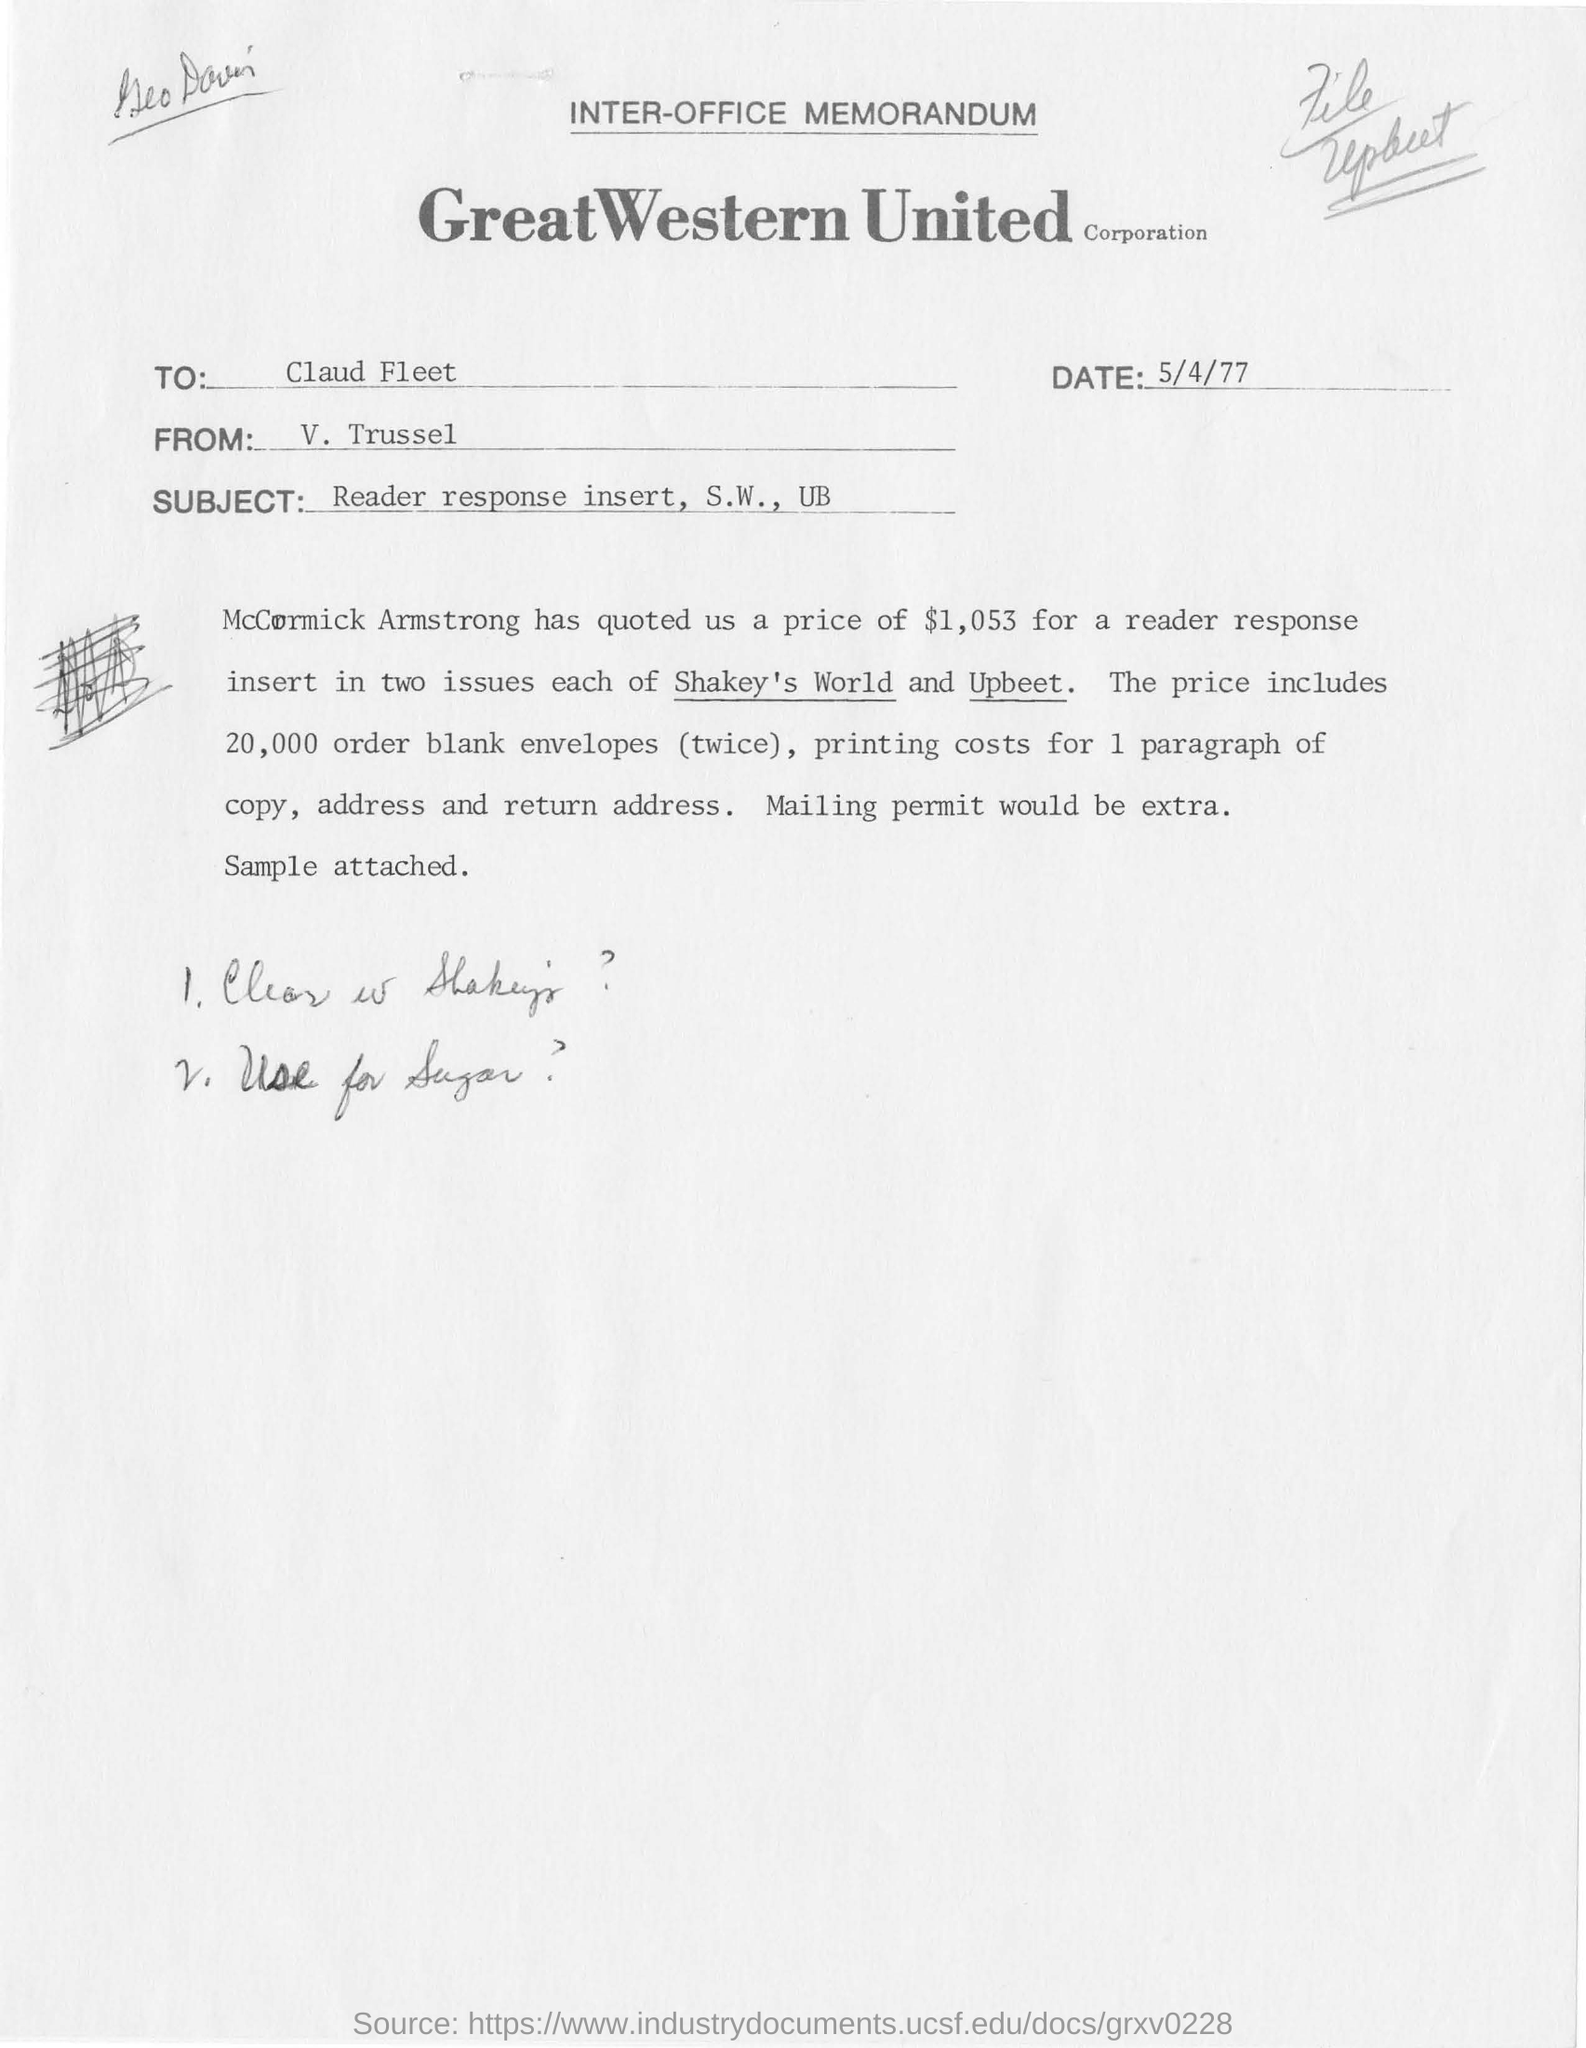To whom this memorandum was written ?
Give a very brief answer. Claud Fleet. Who is the sender of this memorandum?
Provide a succinct answer. V. Trussel. Mention the subject of the memorandum.
Your answer should be compact. Reader response insert, S.W., UB. On which date this memorandum was written ?
Offer a terse response. 5/4/77. What was the price quoted by mccormick armstrong ?
Your answer should be very brief. $1,053. What were the two issues mentioned in the memorandum ?
Provide a short and direct response. Shakey's World and Upbeet. What is the memorandum dated?
Provide a succinct answer. 5/4/77. 